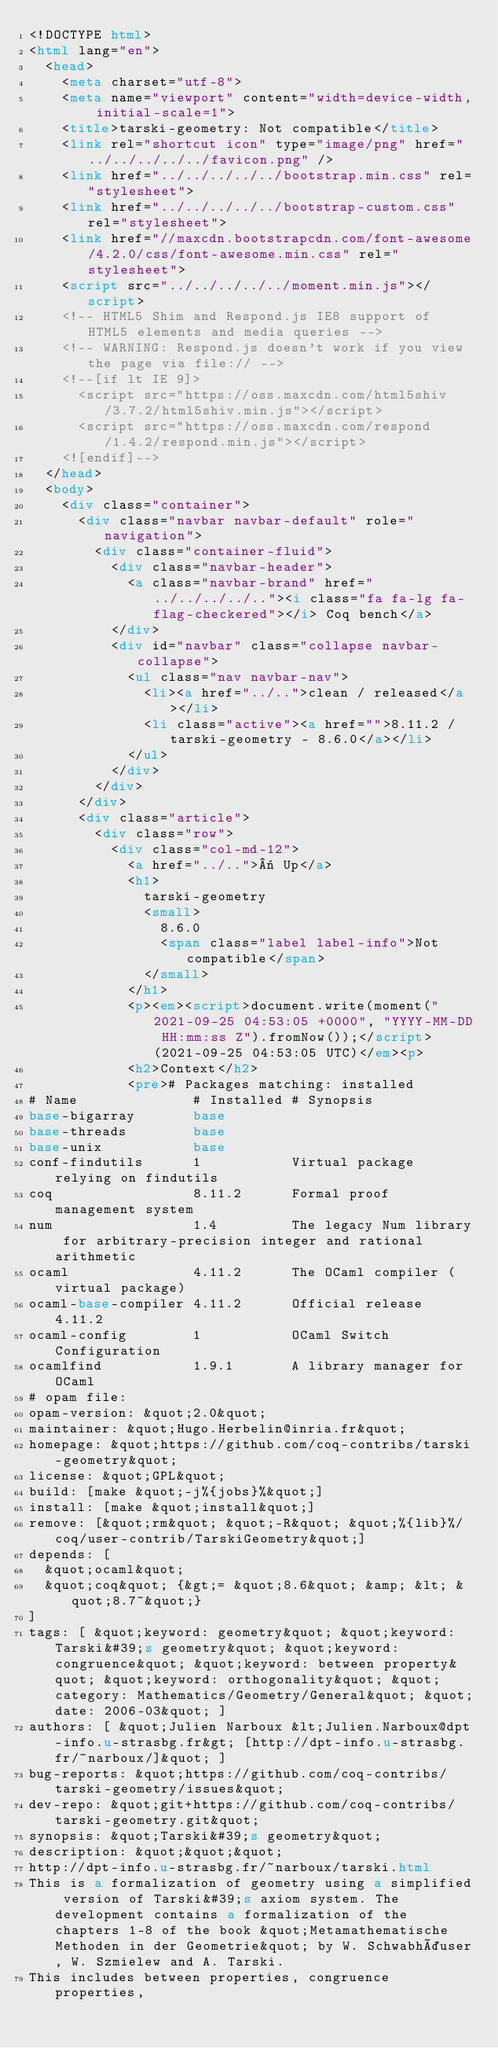<code> <loc_0><loc_0><loc_500><loc_500><_HTML_><!DOCTYPE html>
<html lang="en">
  <head>
    <meta charset="utf-8">
    <meta name="viewport" content="width=device-width, initial-scale=1">
    <title>tarski-geometry: Not compatible</title>
    <link rel="shortcut icon" type="image/png" href="../../../../../favicon.png" />
    <link href="../../../../../bootstrap.min.css" rel="stylesheet">
    <link href="../../../../../bootstrap-custom.css" rel="stylesheet">
    <link href="//maxcdn.bootstrapcdn.com/font-awesome/4.2.0/css/font-awesome.min.css" rel="stylesheet">
    <script src="../../../../../moment.min.js"></script>
    <!-- HTML5 Shim and Respond.js IE8 support of HTML5 elements and media queries -->
    <!-- WARNING: Respond.js doesn't work if you view the page via file:// -->
    <!--[if lt IE 9]>
      <script src="https://oss.maxcdn.com/html5shiv/3.7.2/html5shiv.min.js"></script>
      <script src="https://oss.maxcdn.com/respond/1.4.2/respond.min.js"></script>
    <![endif]-->
  </head>
  <body>
    <div class="container">
      <div class="navbar navbar-default" role="navigation">
        <div class="container-fluid">
          <div class="navbar-header">
            <a class="navbar-brand" href="../../../../.."><i class="fa fa-lg fa-flag-checkered"></i> Coq bench</a>
          </div>
          <div id="navbar" class="collapse navbar-collapse">
            <ul class="nav navbar-nav">
              <li><a href="../..">clean / released</a></li>
              <li class="active"><a href="">8.11.2 / tarski-geometry - 8.6.0</a></li>
            </ul>
          </div>
        </div>
      </div>
      <div class="article">
        <div class="row">
          <div class="col-md-12">
            <a href="../..">« Up</a>
            <h1>
              tarski-geometry
              <small>
                8.6.0
                <span class="label label-info">Not compatible</span>
              </small>
            </h1>
            <p><em><script>document.write(moment("2021-09-25 04:53:05 +0000", "YYYY-MM-DD HH:mm:ss Z").fromNow());</script> (2021-09-25 04:53:05 UTC)</em><p>
            <h2>Context</h2>
            <pre># Packages matching: installed
# Name              # Installed # Synopsis
base-bigarray       base
base-threads        base
base-unix           base
conf-findutils      1           Virtual package relying on findutils
coq                 8.11.2      Formal proof management system
num                 1.4         The legacy Num library for arbitrary-precision integer and rational arithmetic
ocaml               4.11.2      The OCaml compiler (virtual package)
ocaml-base-compiler 4.11.2      Official release 4.11.2
ocaml-config        1           OCaml Switch Configuration
ocamlfind           1.9.1       A library manager for OCaml
# opam file:
opam-version: &quot;2.0&quot;
maintainer: &quot;Hugo.Herbelin@inria.fr&quot;
homepage: &quot;https://github.com/coq-contribs/tarski-geometry&quot;
license: &quot;GPL&quot;
build: [make &quot;-j%{jobs}%&quot;]
install: [make &quot;install&quot;]
remove: [&quot;rm&quot; &quot;-R&quot; &quot;%{lib}%/coq/user-contrib/TarskiGeometry&quot;]
depends: [
  &quot;ocaml&quot;
  &quot;coq&quot; {&gt;= &quot;8.6&quot; &amp; &lt; &quot;8.7~&quot;}
]
tags: [ &quot;keyword: geometry&quot; &quot;keyword: Tarski&#39;s geometry&quot; &quot;keyword: congruence&quot; &quot;keyword: between property&quot; &quot;keyword: orthogonality&quot; &quot;category: Mathematics/Geometry/General&quot; &quot;date: 2006-03&quot; ]
authors: [ &quot;Julien Narboux &lt;Julien.Narboux@dpt-info.u-strasbg.fr&gt; [http://dpt-info.u-strasbg.fr/~narboux/]&quot; ]
bug-reports: &quot;https://github.com/coq-contribs/tarski-geometry/issues&quot;
dev-repo: &quot;git+https://github.com/coq-contribs/tarski-geometry.git&quot;
synopsis: &quot;Tarski&#39;s geometry&quot;
description: &quot;&quot;&quot;
http://dpt-info.u-strasbg.fr/~narboux/tarski.html
This is a formalization of geometry using a simplified version of Tarski&#39;s axiom system. The development contains a formalization of the chapters 1-8 of the book &quot;Metamathematische Methoden in der Geometrie&quot; by W. Schwabhäuser, W. Szmielew and A. Tarski.
This includes between properties, congruence properties,</code> 